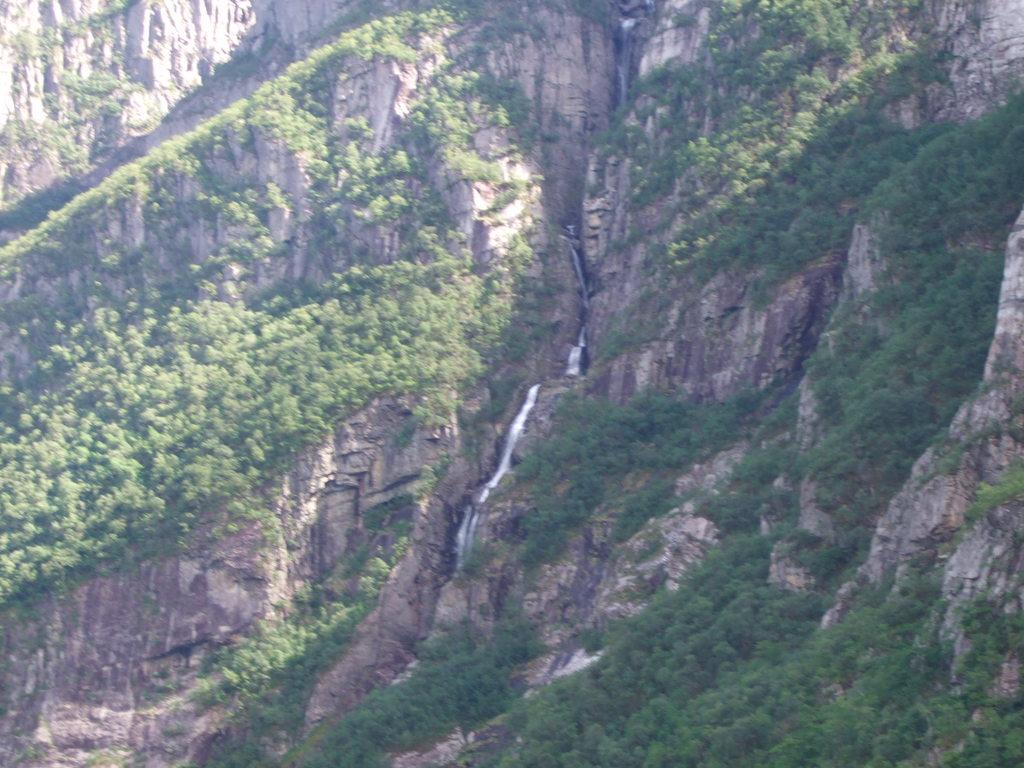What is the main geographical feature in the image? There is a mountain in the image. What can be seen on the mountain? There are trees on the mountain. What natural element is present in the image? There is a water flow in the image. What type of canvas is being used to paint the mountain in the image? There is no canvas present in the image, as it is a photograph or illustration of a mountain, not a painting. 